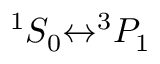<formula> <loc_0><loc_0><loc_500><loc_500>^ { 1 } S _ { 0 } { \leftrightarrow } ^ { 3 } P _ { 1 }</formula> 